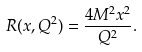Convert formula to latex. <formula><loc_0><loc_0><loc_500><loc_500>R ( x , Q ^ { 2 } ) = \frac { 4 M ^ { 2 } x ^ { 2 } } { Q ^ { 2 } } .</formula> 